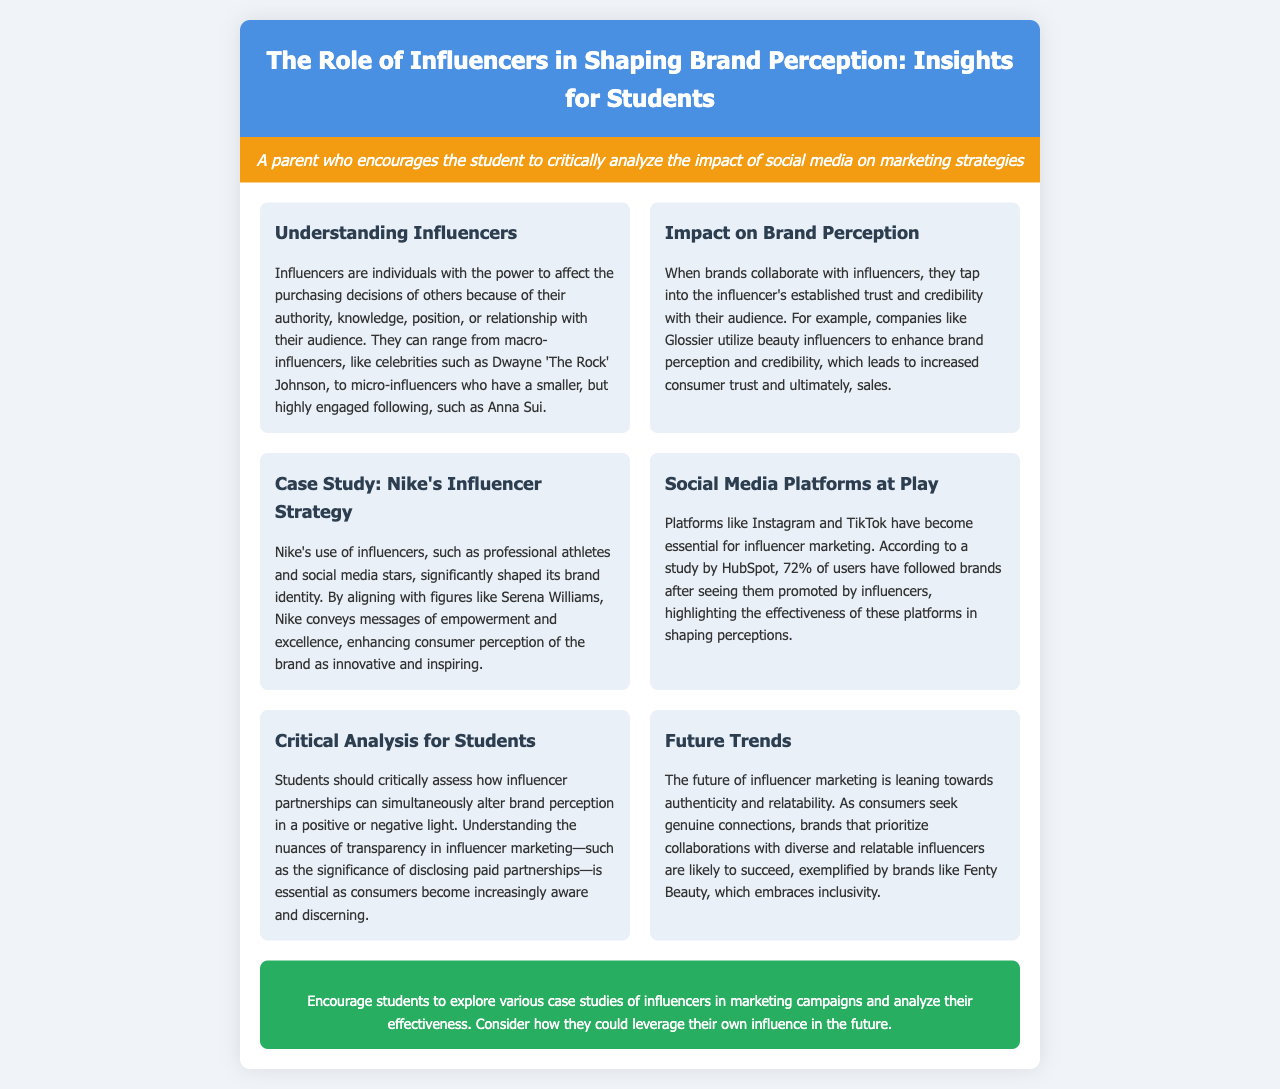What is the title of the brochure? The title is the main heading presented at the top of the document, which elaborates on the content inside.
Answer: The Role of Influencers in Shaping Brand Perception: Insights for Students Who is an example of a macro-influencer mentioned in the document? The document lists a specific celebrity known for having a large following as an example of a macro-influencer.
Answer: Dwayne 'The Rock' Johnson What percentage of users have followed brands after seeing them promoted by influencers? The document cites a statistic from a study that highlights the effectiveness of influencers in promoting brands.
Answer: 72% Which company is mentioned as utilizing beauty influencers? This company is specifically noted for enhancing its brand perception through collaborations with beauty influencers.
Answer: Glossier What is a critical aspect students should understand about influencer marketing? The document emphasizes the importance of a specific practice in influencer marketing that relates to honesty and consumer trust.
Answer: Transparency Which brand is highlighted for embracing inclusivity in its marketing strategy? This brand is recognized in the document for its focus on diverse and relatable influencer collaborations.
Answer: Fenty Beauty What does Nike convey through its influencer partnerships? The document explains the messages that Nike transmits by aligning with athletes and social media stars.
Answer: Empowerment and excellence What do the sections in the brochure primarily consist of? The sections are structured to address different themes pertinent to the role of influencers in marketing.
Answer: Key insights and analysis 